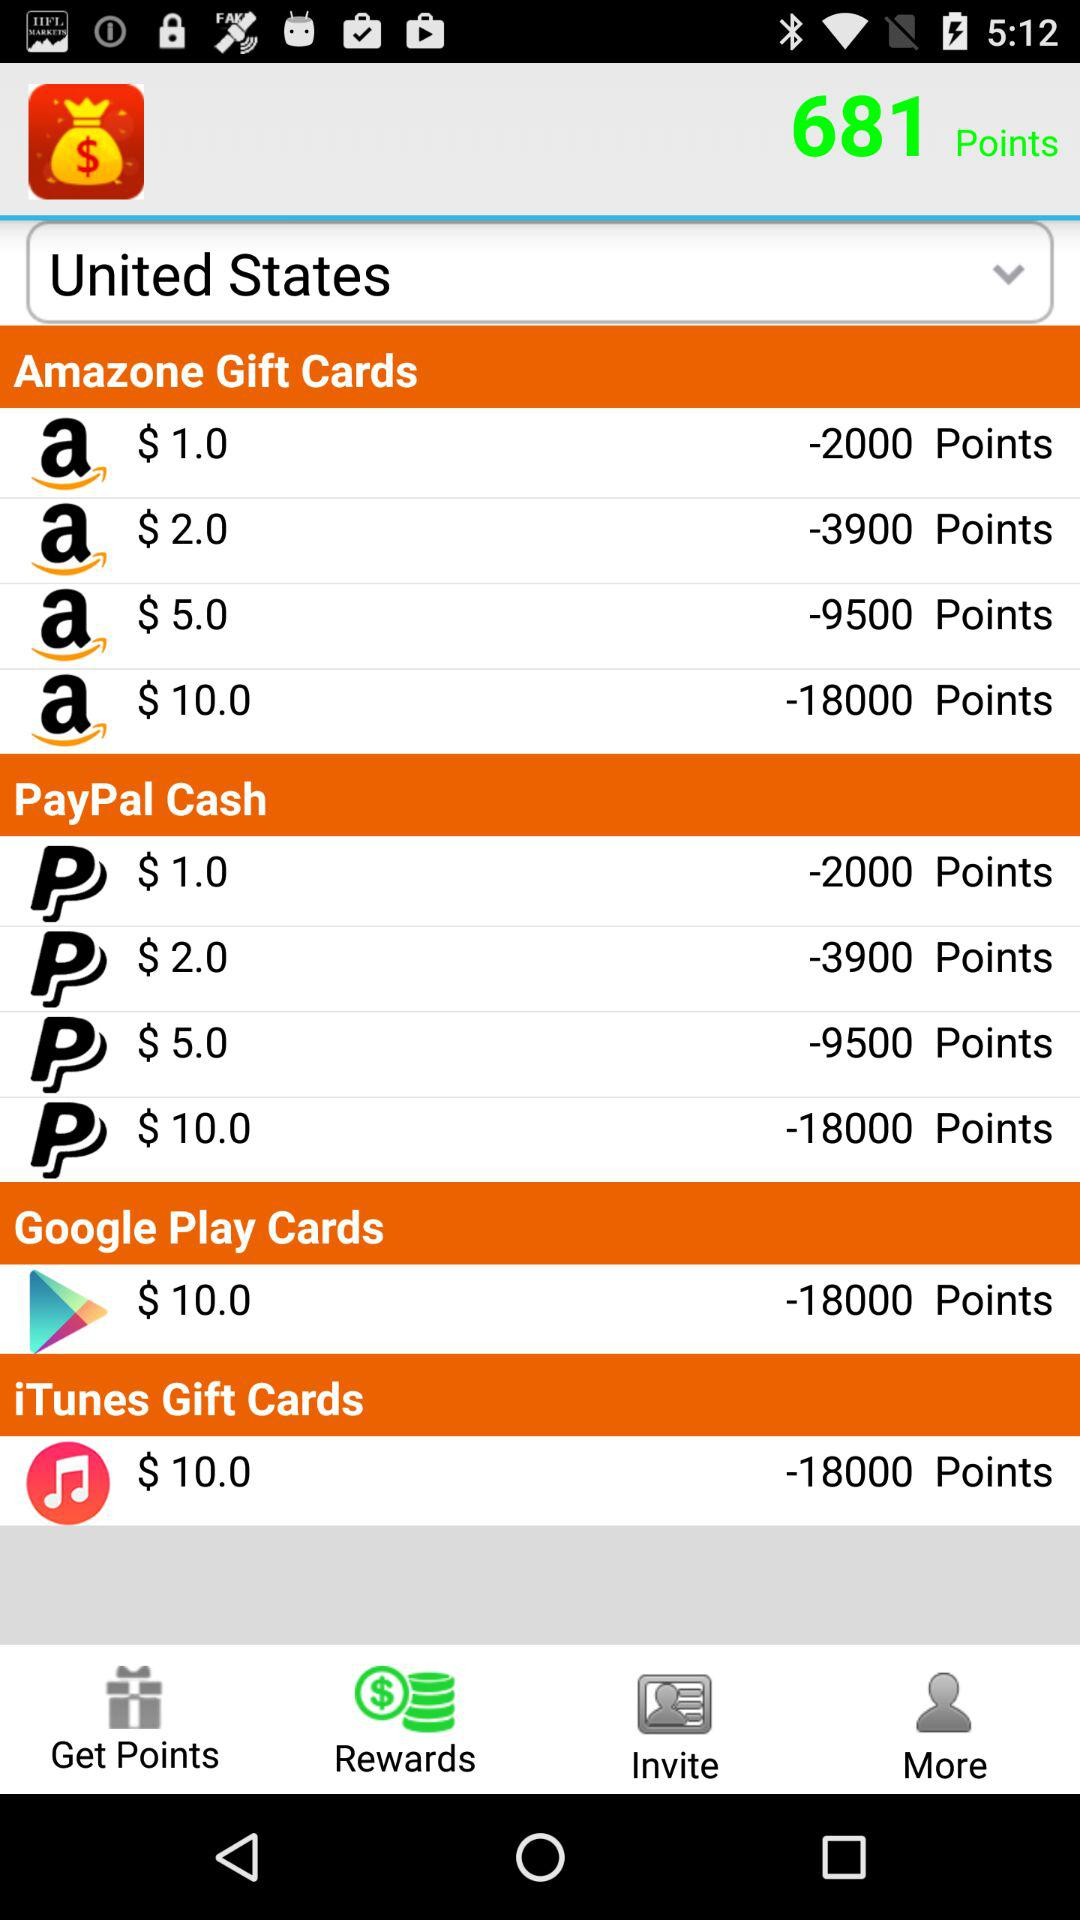How many Google Play Cards are available?
Answer the question using a single word or phrase. 1 